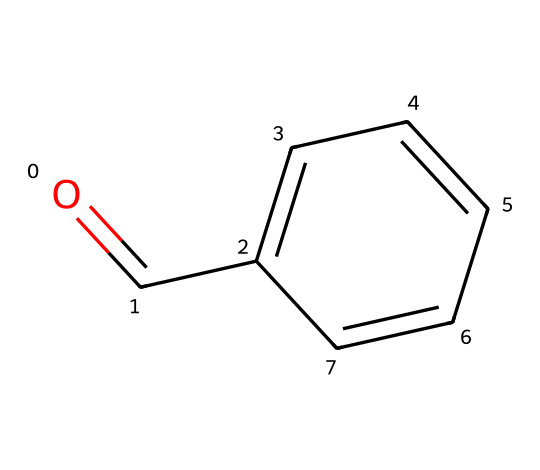What is the molecular formula of benzaldehyde? By interpreting the SMILES representation, we can identify the components: there are 7 carbon atoms, 6 hydrogen atoms, and 1 oxygen atom. This leads to the molecular formula C7H6O.
Answer: C7H6O How many aromatic carbon atoms are present in benzaldehyde? The structure shows that there are 6 carbon atoms in the benzene ring, which is characteristic of aromatic compounds. Thus, there are 6 aromatic carbon atoms.
Answer: 6 What type of functional group is present in benzaldehyde? The presence of the carbonyl group (C=O) directly connected to one of the carbon atoms of the benzene ring indicates that the functional group is an aldehyde.
Answer: aldehyde How many double bonds are in the benzaldehyde structure? The structure reveals one double bond in the carbonyl group (C=O) and three double bonds in the benzene ring, totaling four double bonds in the molecule.
Answer: 4 What indication does the presence of the carbonyl group (C=O) give about the reactivity of benzaldehyde? The carbonyl group is a characteristic feature of aldehydes, making them more reactive than alkanes or aromatic rings due to the polarization of the C=O bond, which tends to undergo nucleophilic attacks.
Answer: more reactive What flavor profile is primarily associated with benzaldehyde? Benzaldehyde is well-known for its sweet, almond-like flavor, making it a common flavoring agent in food products and perfumes.
Answer: almond-like 